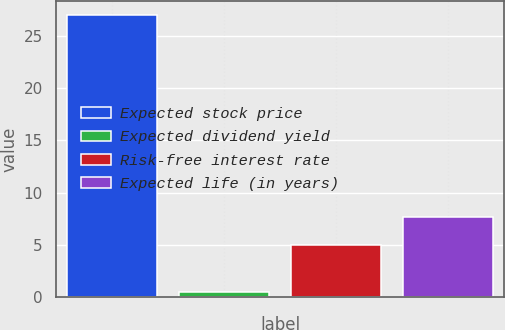Convert chart. <chart><loc_0><loc_0><loc_500><loc_500><bar_chart><fcel>Expected stock price<fcel>Expected dividend yield<fcel>Risk-free interest rate<fcel>Expected life (in years)<nl><fcel>27<fcel>0.5<fcel>5<fcel>7.65<nl></chart> 